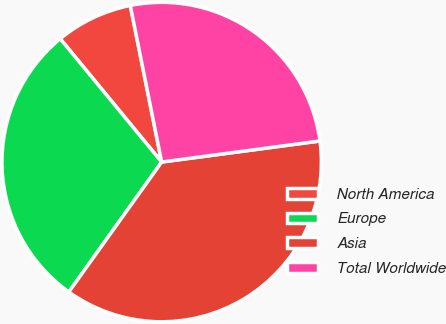<chart> <loc_0><loc_0><loc_500><loc_500><pie_chart><fcel>North America<fcel>Europe<fcel>Asia<fcel>Total Worldwide<nl><fcel>7.81%<fcel>29.17%<fcel>36.98%<fcel>26.04%<nl></chart> 